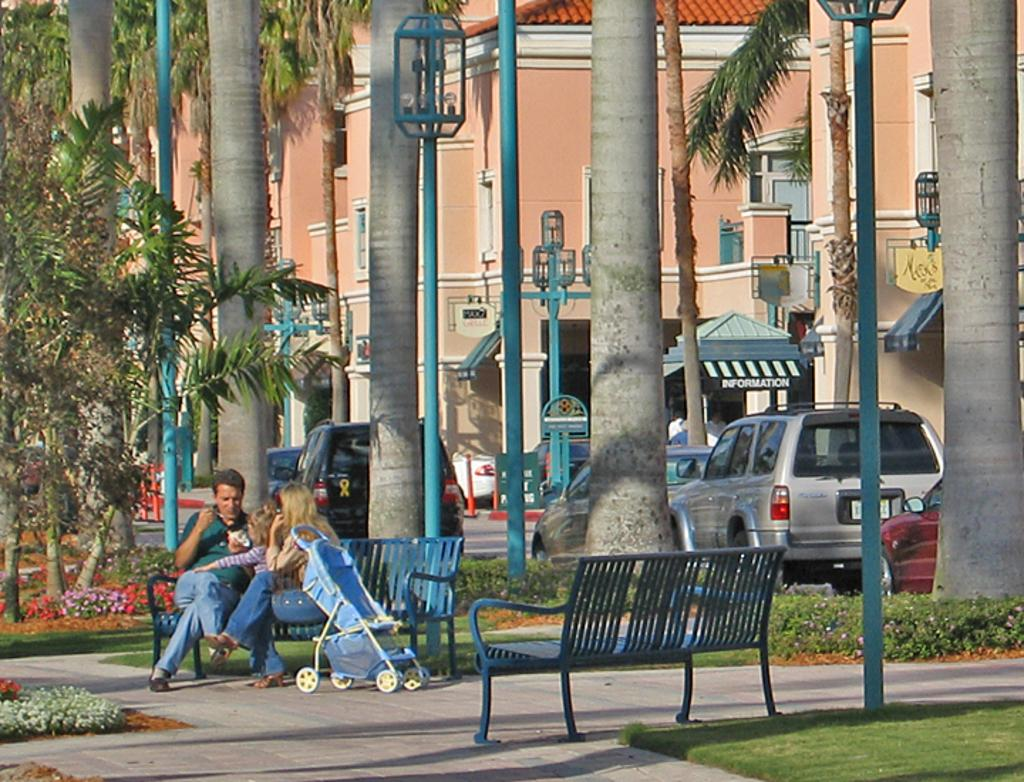What type of structures can be seen in the image? There are buildings in the image. What natural elements are present in the image? There are trees in the image. What architectural features can be seen in the image? Windows, light-poles, traffic poles, and a shed are visible in the image. What type of seating is available in the image? Benches are present in the image. What mode of transportation is visible in the image? Vehicles and a trolley are visible in the image. What type of flora can be seen in the image? Colorful flowers are visible in the image. Are there any people present in the image? Yes, there are people sitting on the bench in the image. Is there a spy observing the scene from a hidden location in the image? There is no indication of a spy or any hidden location in the image. Which direction is north in the image? The image does not provide any information about the cardinal directions, so it is impossible to determine which direction is north. 